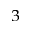<formula> <loc_0><loc_0><loc_500><loc_500>^ { 3 }</formula> 